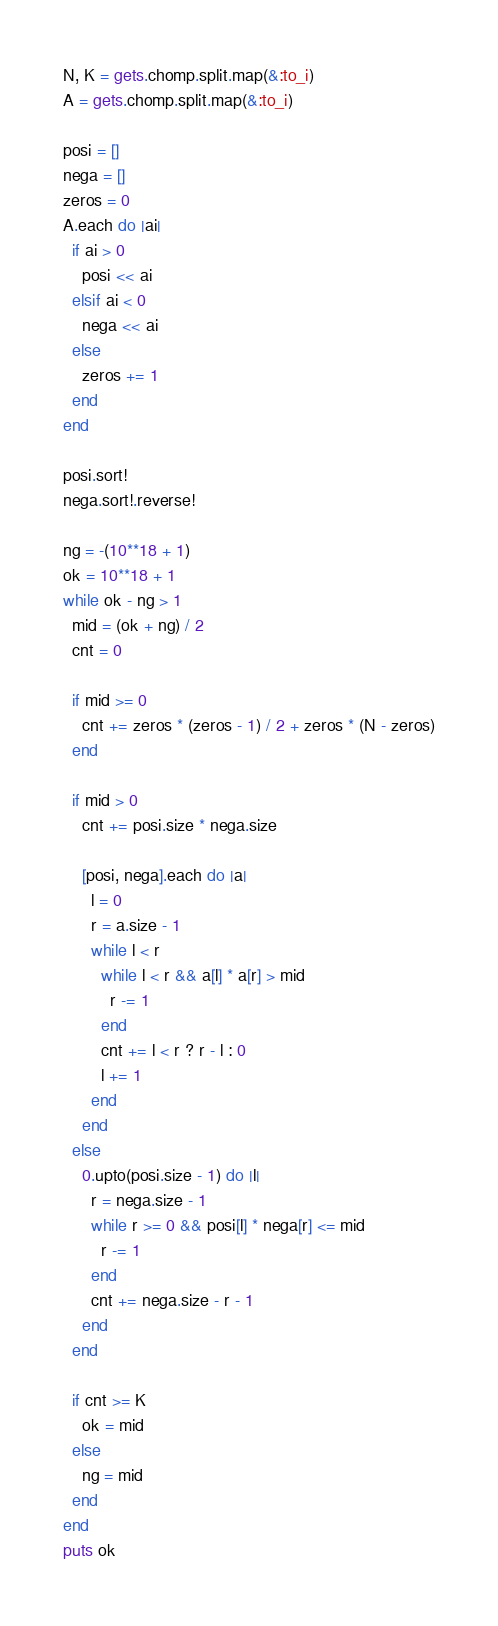Convert code to text. <code><loc_0><loc_0><loc_500><loc_500><_Ruby_>N, K = gets.chomp.split.map(&:to_i)
A = gets.chomp.split.map(&:to_i)

posi = []
nega = []
zeros = 0
A.each do |ai|
  if ai > 0
    posi << ai
  elsif ai < 0
    nega << ai
  else
    zeros += 1
  end
end

posi.sort!
nega.sort!.reverse!

ng = -(10**18 + 1)
ok = 10**18 + 1
while ok - ng > 1
  mid = (ok + ng) / 2
  cnt = 0

  if mid >= 0
    cnt += zeros * (zeros - 1) / 2 + zeros * (N - zeros)
  end

  if mid > 0
    cnt += posi.size * nega.size

    [posi, nega].each do |a|
      l = 0
      r = a.size - 1
      while l < r
        while l < r && a[l] * a[r] > mid
          r -= 1
        end
        cnt += l < r ? r - l : 0
        l += 1
      end
    end
  else
    0.upto(posi.size - 1) do |l|
      r = nega.size - 1
      while r >= 0 && posi[l] * nega[r] <= mid
        r -= 1
      end
      cnt += nega.size - r - 1
    end
  end

  if cnt >= K
    ok = mid
  else
    ng = mid
  end
end
puts ok</code> 